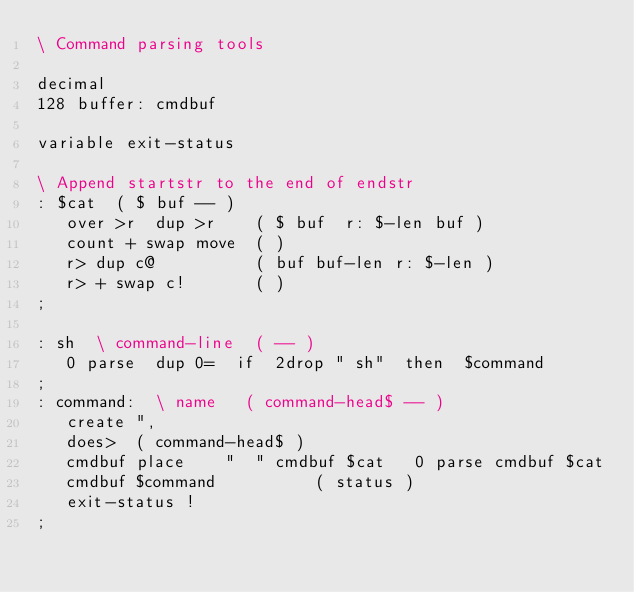<code> <loc_0><loc_0><loc_500><loc_500><_Forth_>\ Command parsing tools

decimal
128 buffer: cmdbuf 

variable exit-status

\ Append startstr to the end of endstr
: $cat  ( $ buf -- )
   over >r  dup >r    ( $ buf  r: $-len buf )
   count + swap move  ( )
   r> dup c@          ( buf buf-len r: $-len )
   r> + swap c!       ( )
;

: sh  \ command-line  ( -- )
   0 parse  dup 0=  if  2drop " sh"  then  $command
;
: command:  \ name   ( command-head$ -- )
   create ",
   does>  ( command-head$ )
   cmdbuf place    "  " cmdbuf $cat   0 parse cmdbuf $cat
   cmdbuf $command          ( status )
   exit-status !
;

</code> 